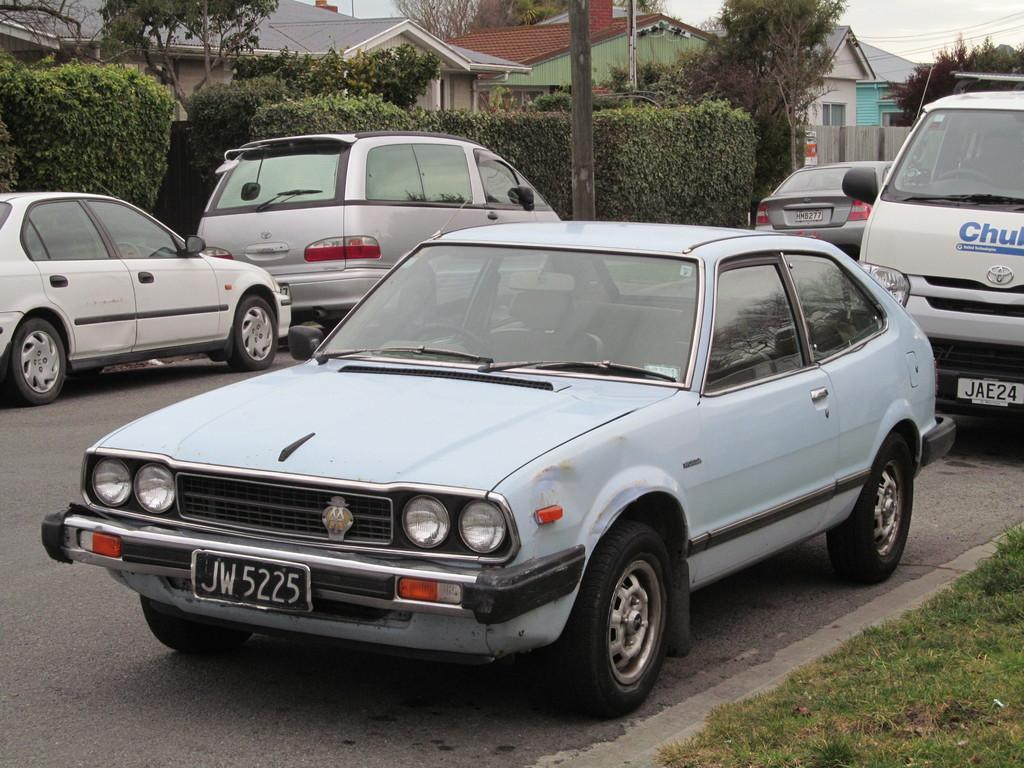What is the main feature of the image? There is a road in the image. What is happening on the road? There are vehicles on the road. What type of ground surface is visible in the image? There is grass on the ground. What else can be seen in the image besides the road and vehicles? There is a pole, trees, buildings, and the sky is visible in the background. What type of clouds can be seen in the image? There are no clouds visible in the image; the sky is visible in the background, but no clouds are mentioned in the facts. Can you tell me how many basketballs are present in the image? There are no basketballs present in the image; the facts mention vehicles, grass, a pole, trees, buildings, and the sky, but not any basketballs. 